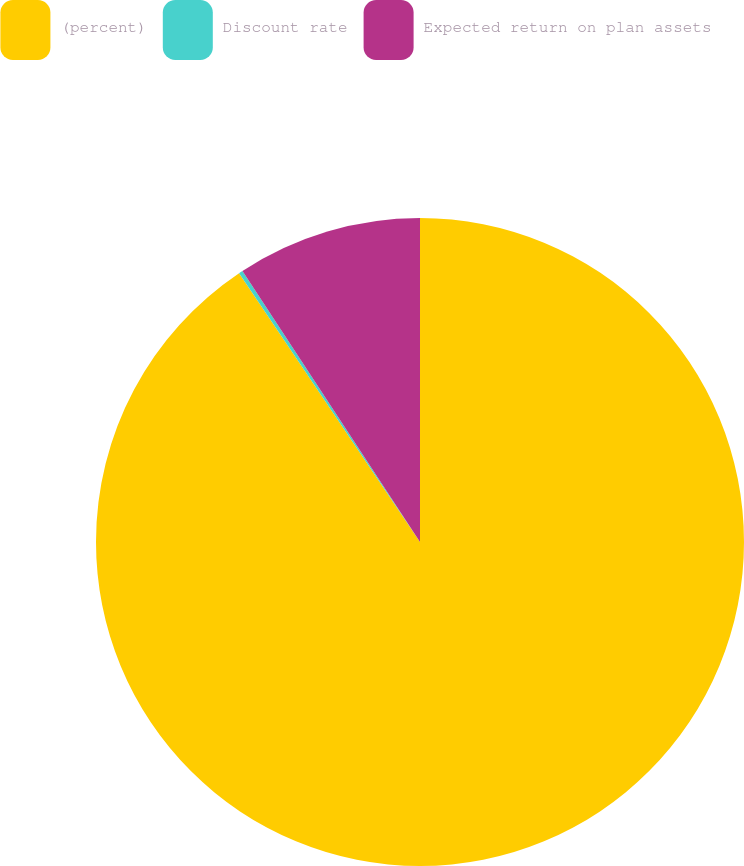Convert chart to OTSL. <chart><loc_0><loc_0><loc_500><loc_500><pie_chart><fcel>(percent)<fcel>Discount rate<fcel>Expected return on plan assets<nl><fcel>90.57%<fcel>0.2%<fcel>9.23%<nl></chart> 